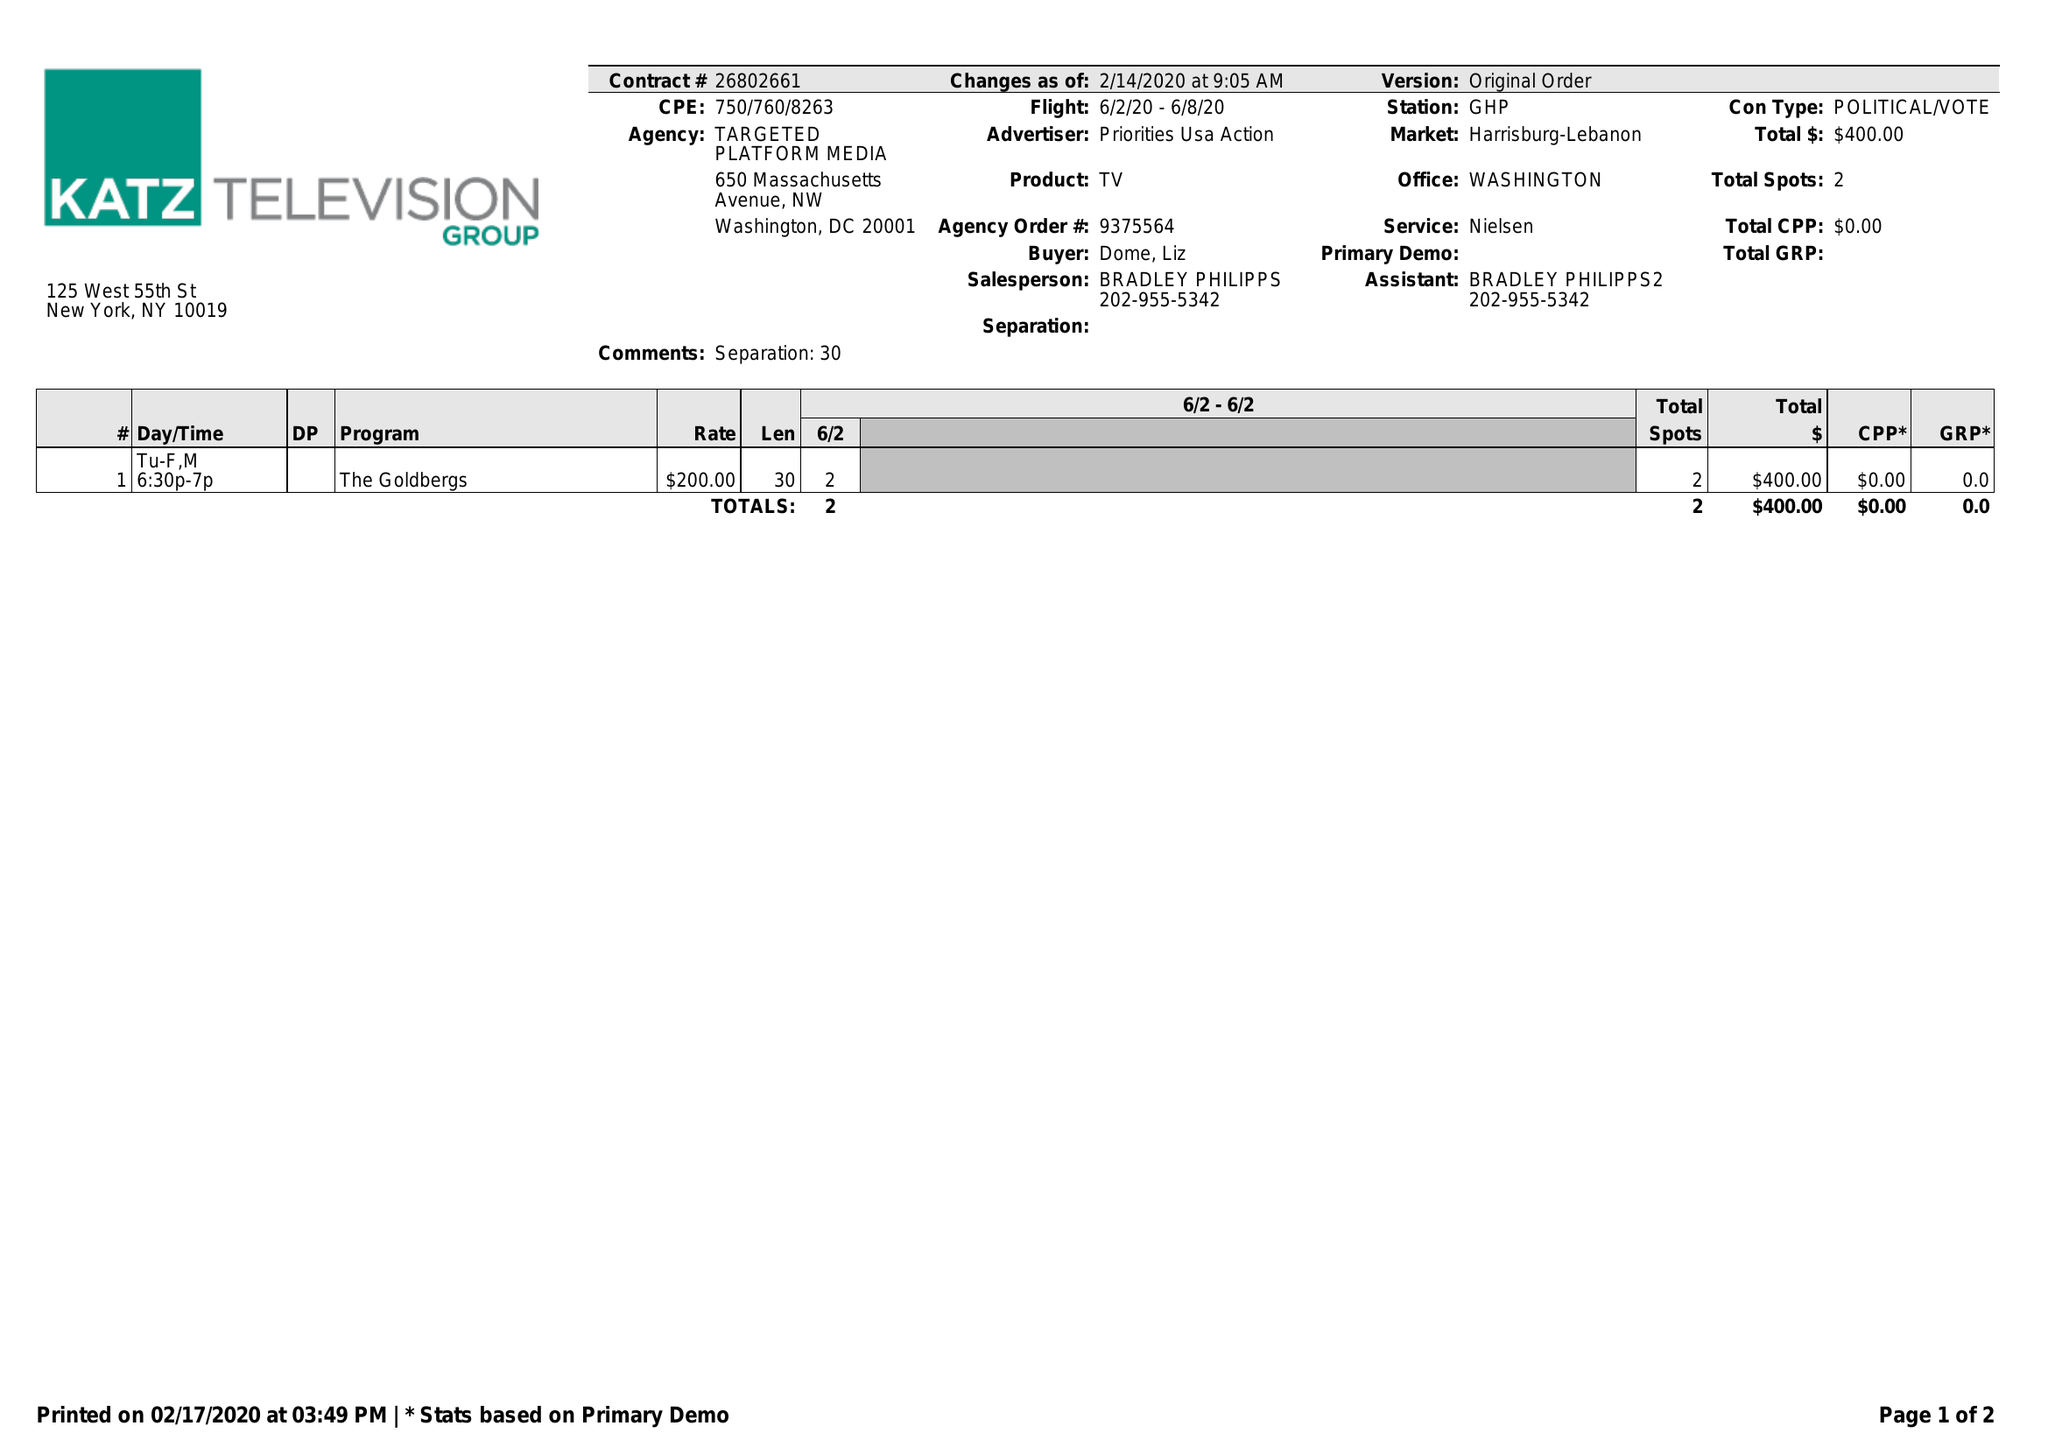What is the value for the flight_from?
Answer the question using a single word or phrase. 06/02/20 